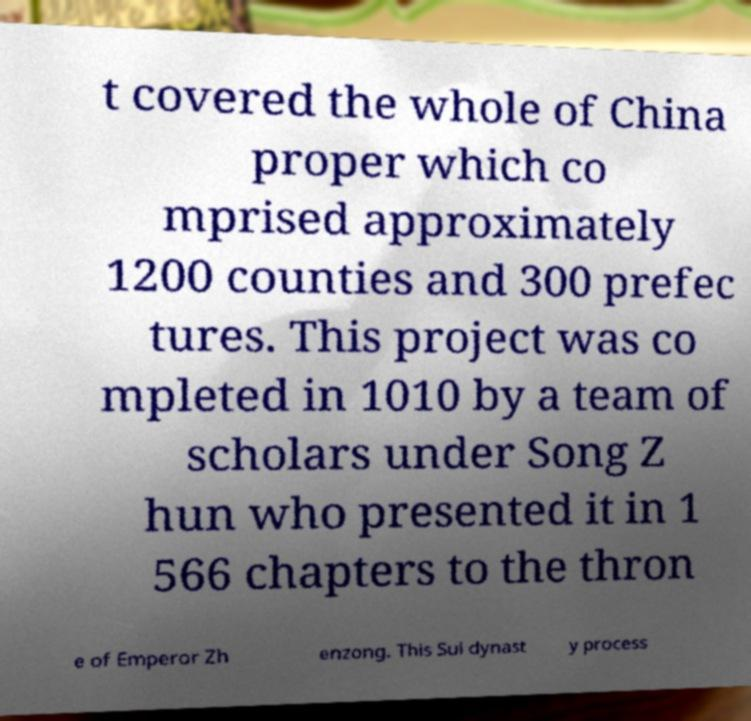Please identify and transcribe the text found in this image. t covered the whole of China proper which co mprised approximately 1200 counties and 300 prefec tures. This project was co mpleted in 1010 by a team of scholars under Song Z hun who presented it in 1 566 chapters to the thron e of Emperor Zh enzong. This Sui dynast y process 